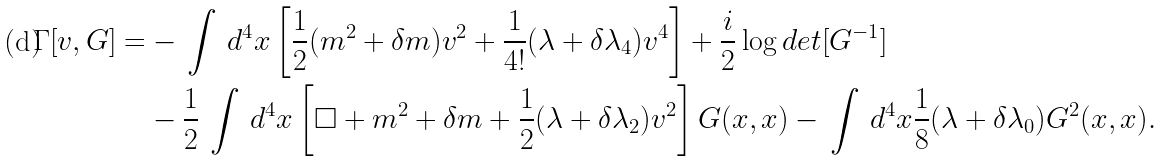Convert formula to latex. <formula><loc_0><loc_0><loc_500><loc_500>\Gamma [ v , G ] = & - \, \int \, d ^ { 4 } x \left [ \frac { 1 } { 2 } ( m ^ { 2 } + \delta m ) v ^ { 2 } + \frac { 1 } { 4 ! } ( \lambda + \delta \lambda _ { 4 } ) v ^ { 4 } \right ] + \frac { i } { 2 } \log d e t [ G ^ { - 1 } ] \\ & - \frac { 1 } { 2 } \, \int \, d ^ { 4 } x \left [ \Box + m ^ { 2 } + \delta m + \frac { 1 } { 2 } ( \lambda + \delta \lambda _ { 2 } ) v ^ { 2 } \right ] G ( x , x ) - \, \int \, d ^ { 4 } x \frac { 1 } { 8 } ( \lambda + \delta \lambda _ { 0 } ) G ^ { 2 } ( x , x ) .</formula> 